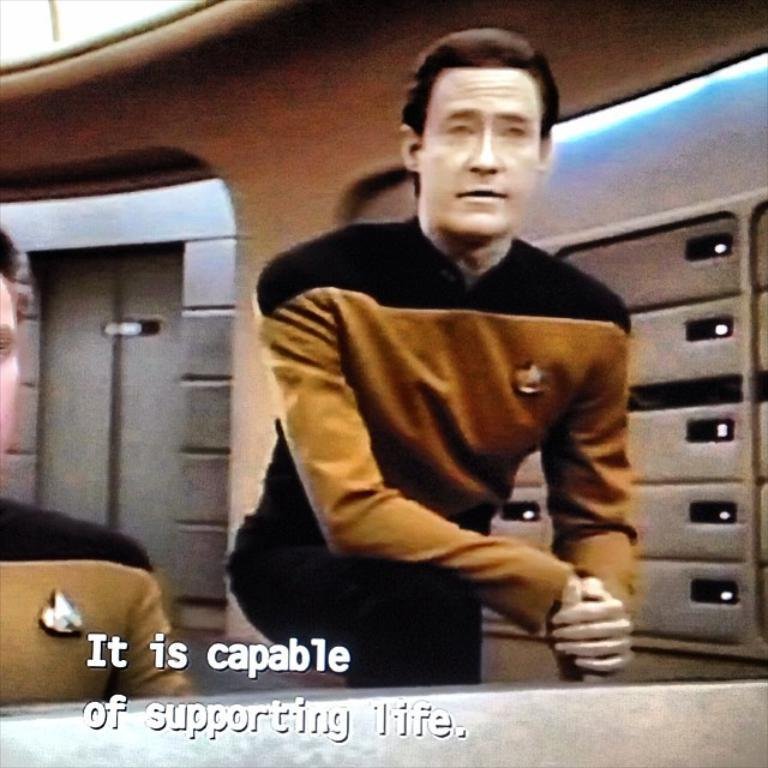What type of image is being described? The image appears to be animated. How many people are visible in the foreground of the image? There are two persons in the foreground of the image. What can be found at the bottom of the image? There is text at the bottom of the image. What type of objects can be seen in the background of the image? There are lockers and a wall in the background of the image. What reason do the fairies have for visiting the sister in the image? There are no fairies or sisters present in the image, so it is not possible to determine a reason for their interaction. 